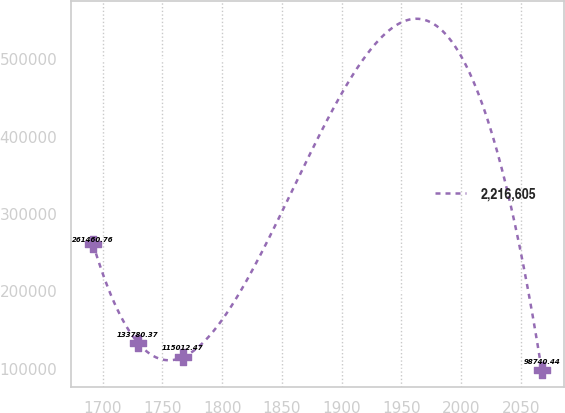Convert chart. <chart><loc_0><loc_0><loc_500><loc_500><line_chart><ecel><fcel>2,216,605<nl><fcel>1691.98<fcel>261461<nl><fcel>1729.53<fcel>133780<nl><fcel>1767.08<fcel>115012<nl><fcel>2067.49<fcel>98740.4<nl></chart> 